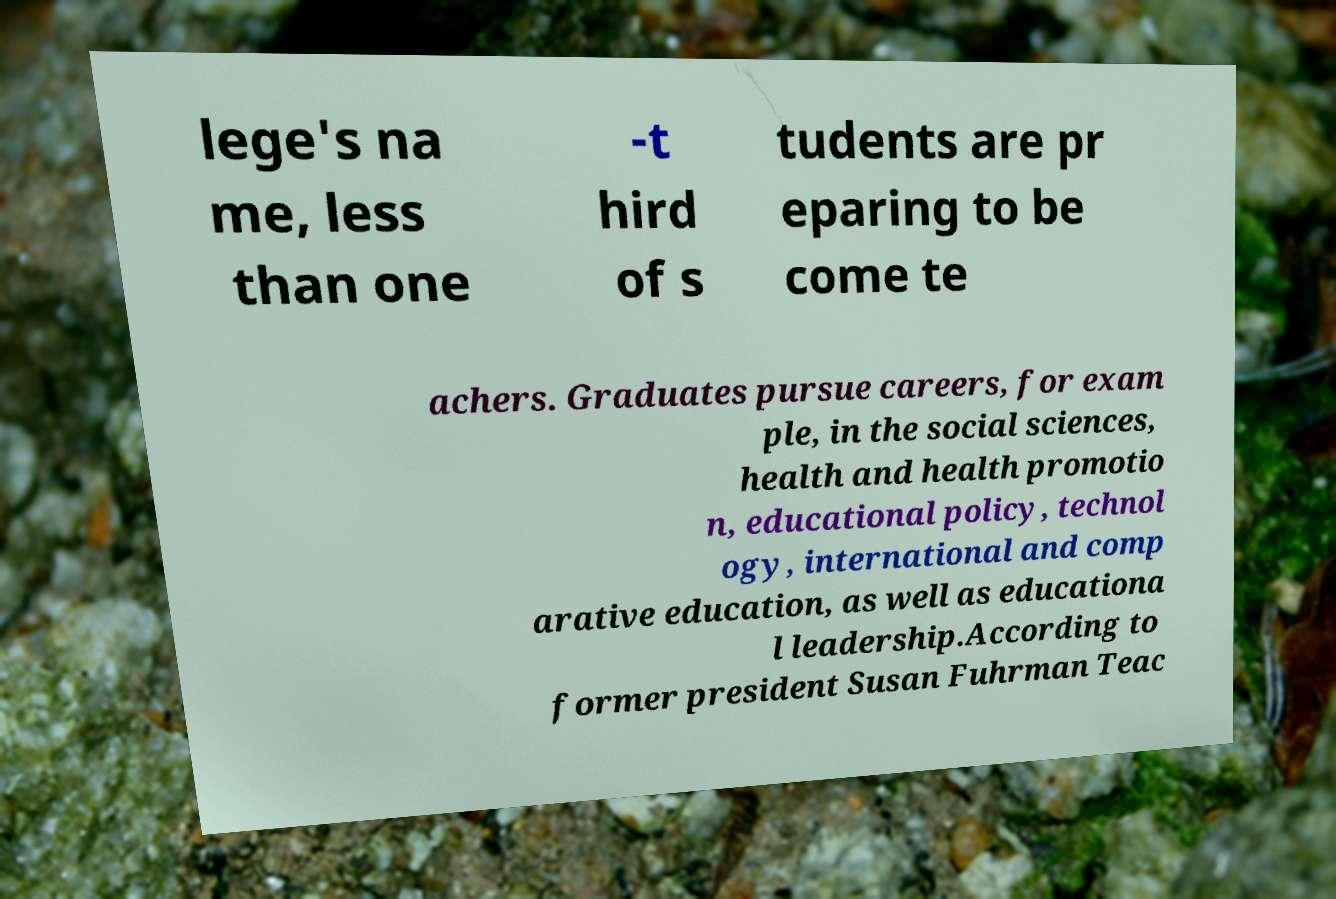Please read and relay the text visible in this image. What does it say? lege's na me, less than one -t hird of s tudents are pr eparing to be come te achers. Graduates pursue careers, for exam ple, in the social sciences, health and health promotio n, educational policy, technol ogy, international and comp arative education, as well as educationa l leadership.According to former president Susan Fuhrman Teac 